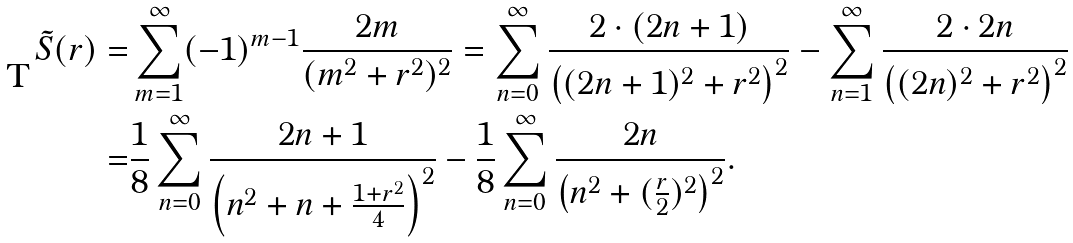Convert formula to latex. <formula><loc_0><loc_0><loc_500><loc_500>\tilde { S } ( r ) = & \sum _ { m = 1 } ^ { \infty } ( - 1 ) ^ { m - 1 } \frac { 2 m } { ( m ^ { 2 } + r ^ { 2 } ) ^ { 2 } } = \sum _ { n = 0 } ^ { \infty } \frac { 2 \cdot ( 2 n + 1 ) } { \left ( ( 2 n + 1 ) ^ { 2 } + r ^ { 2 } \right ) ^ { 2 } } - \sum _ { n = 1 } ^ { \infty } \frac { 2 \cdot 2 n } { \left ( ( 2 n ) ^ { 2 } + r ^ { 2 } \right ) ^ { 2 } } \\ = & \frac { 1 } { 8 } \sum _ { n = 0 } ^ { \infty } \frac { 2 n + 1 } { \left ( n ^ { 2 } + n + \frac { 1 + r ^ { 2 } } { 4 } \right ) ^ { 2 } } - \frac { 1 } { 8 } \sum _ { n = 0 } ^ { \infty } \frac { 2 n } { \left ( n ^ { 2 } + ( \frac { r } { 2 } ) ^ { 2 } \right ) ^ { 2 } } .</formula> 